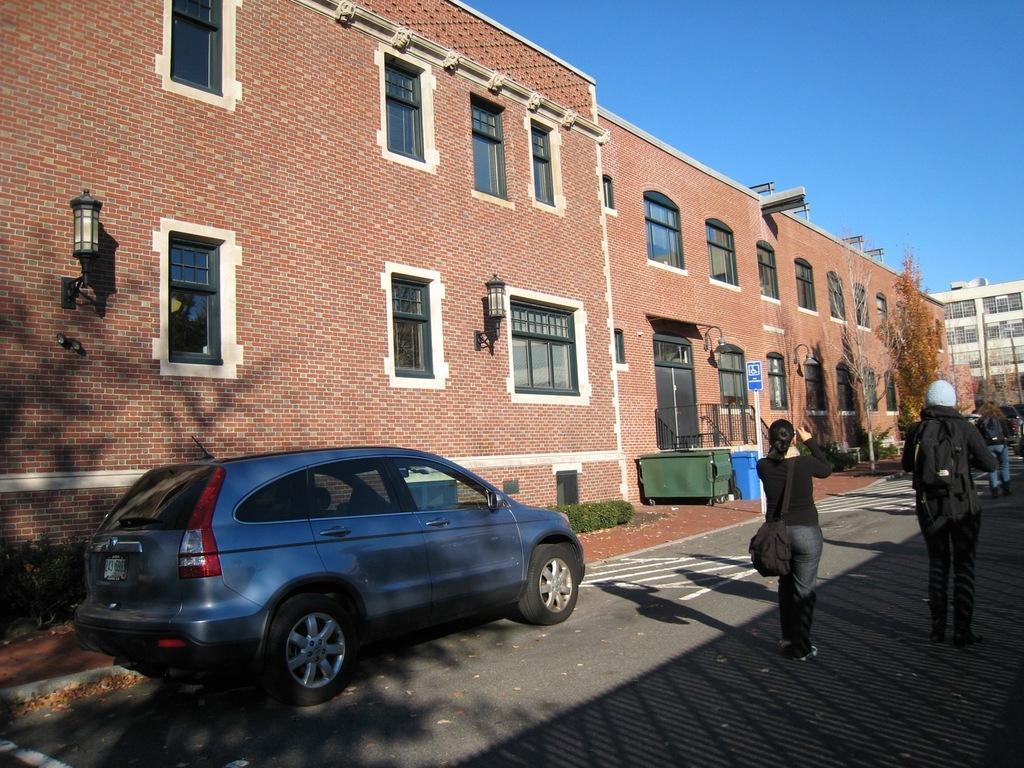Could you give a brief overview of what you see in this image? In this picture we can see the brown brick building with glass windows. In the front there is a blue car parked on the road side and two couple standing on the road and taking photographs. 